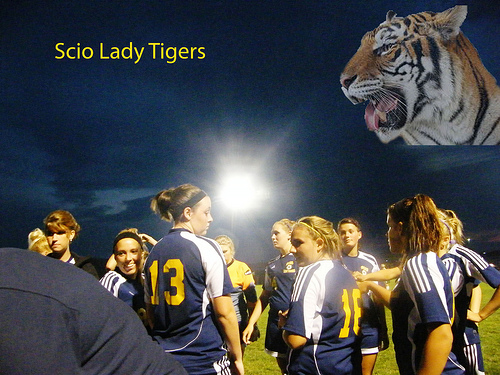<image>
Can you confirm if the tiger is above the girl? Yes. The tiger is positioned above the girl in the vertical space, higher up in the scene. 